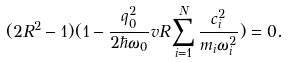<formula> <loc_0><loc_0><loc_500><loc_500>( 2 R ^ { 2 } - 1 ) ( 1 - \frac { q ^ { 2 } _ { 0 } } { 2 \hbar { \omega } _ { 0 } } v R \sum _ { i = 1 } ^ { N } \frac { c _ { i } ^ { 2 } } { m _ { i } \omega _ { i } ^ { 2 } } ) = 0 .</formula> 